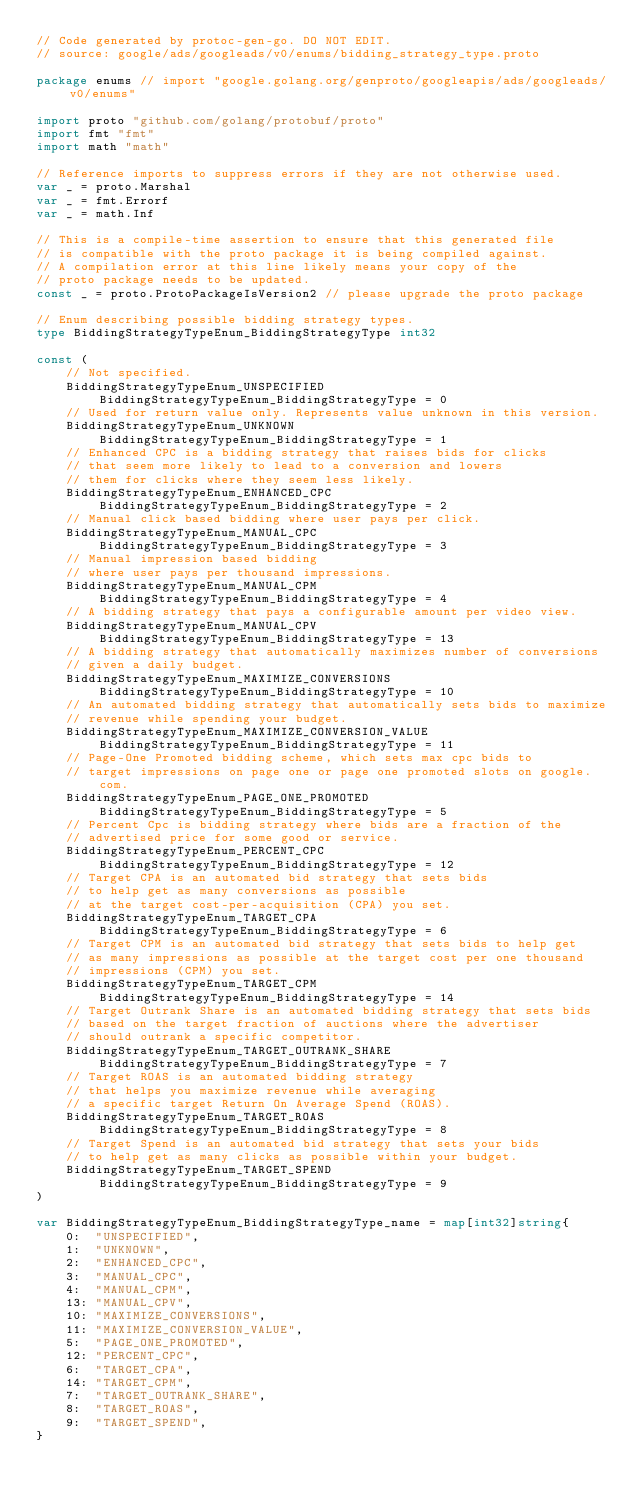<code> <loc_0><loc_0><loc_500><loc_500><_Go_>// Code generated by protoc-gen-go. DO NOT EDIT.
// source: google/ads/googleads/v0/enums/bidding_strategy_type.proto

package enums // import "google.golang.org/genproto/googleapis/ads/googleads/v0/enums"

import proto "github.com/golang/protobuf/proto"
import fmt "fmt"
import math "math"

// Reference imports to suppress errors if they are not otherwise used.
var _ = proto.Marshal
var _ = fmt.Errorf
var _ = math.Inf

// This is a compile-time assertion to ensure that this generated file
// is compatible with the proto package it is being compiled against.
// A compilation error at this line likely means your copy of the
// proto package needs to be updated.
const _ = proto.ProtoPackageIsVersion2 // please upgrade the proto package

// Enum describing possible bidding strategy types.
type BiddingStrategyTypeEnum_BiddingStrategyType int32

const (
	// Not specified.
	BiddingStrategyTypeEnum_UNSPECIFIED BiddingStrategyTypeEnum_BiddingStrategyType = 0
	// Used for return value only. Represents value unknown in this version.
	BiddingStrategyTypeEnum_UNKNOWN BiddingStrategyTypeEnum_BiddingStrategyType = 1
	// Enhanced CPC is a bidding strategy that raises bids for clicks
	// that seem more likely to lead to a conversion and lowers
	// them for clicks where they seem less likely.
	BiddingStrategyTypeEnum_ENHANCED_CPC BiddingStrategyTypeEnum_BiddingStrategyType = 2
	// Manual click based bidding where user pays per click.
	BiddingStrategyTypeEnum_MANUAL_CPC BiddingStrategyTypeEnum_BiddingStrategyType = 3
	// Manual impression based bidding
	// where user pays per thousand impressions.
	BiddingStrategyTypeEnum_MANUAL_CPM BiddingStrategyTypeEnum_BiddingStrategyType = 4
	// A bidding strategy that pays a configurable amount per video view.
	BiddingStrategyTypeEnum_MANUAL_CPV BiddingStrategyTypeEnum_BiddingStrategyType = 13
	// A bidding strategy that automatically maximizes number of conversions
	// given a daily budget.
	BiddingStrategyTypeEnum_MAXIMIZE_CONVERSIONS BiddingStrategyTypeEnum_BiddingStrategyType = 10
	// An automated bidding strategy that automatically sets bids to maximize
	// revenue while spending your budget.
	BiddingStrategyTypeEnum_MAXIMIZE_CONVERSION_VALUE BiddingStrategyTypeEnum_BiddingStrategyType = 11
	// Page-One Promoted bidding scheme, which sets max cpc bids to
	// target impressions on page one or page one promoted slots on google.com.
	BiddingStrategyTypeEnum_PAGE_ONE_PROMOTED BiddingStrategyTypeEnum_BiddingStrategyType = 5
	// Percent Cpc is bidding strategy where bids are a fraction of the
	// advertised price for some good or service.
	BiddingStrategyTypeEnum_PERCENT_CPC BiddingStrategyTypeEnum_BiddingStrategyType = 12
	// Target CPA is an automated bid strategy that sets bids
	// to help get as many conversions as possible
	// at the target cost-per-acquisition (CPA) you set.
	BiddingStrategyTypeEnum_TARGET_CPA BiddingStrategyTypeEnum_BiddingStrategyType = 6
	// Target CPM is an automated bid strategy that sets bids to help get
	// as many impressions as possible at the target cost per one thousand
	// impressions (CPM) you set.
	BiddingStrategyTypeEnum_TARGET_CPM BiddingStrategyTypeEnum_BiddingStrategyType = 14
	// Target Outrank Share is an automated bidding strategy that sets bids
	// based on the target fraction of auctions where the advertiser
	// should outrank a specific competitor.
	BiddingStrategyTypeEnum_TARGET_OUTRANK_SHARE BiddingStrategyTypeEnum_BiddingStrategyType = 7
	// Target ROAS is an automated bidding strategy
	// that helps you maximize revenue while averaging
	// a specific target Return On Average Spend (ROAS).
	BiddingStrategyTypeEnum_TARGET_ROAS BiddingStrategyTypeEnum_BiddingStrategyType = 8
	// Target Spend is an automated bid strategy that sets your bids
	// to help get as many clicks as possible within your budget.
	BiddingStrategyTypeEnum_TARGET_SPEND BiddingStrategyTypeEnum_BiddingStrategyType = 9
)

var BiddingStrategyTypeEnum_BiddingStrategyType_name = map[int32]string{
	0:  "UNSPECIFIED",
	1:  "UNKNOWN",
	2:  "ENHANCED_CPC",
	3:  "MANUAL_CPC",
	4:  "MANUAL_CPM",
	13: "MANUAL_CPV",
	10: "MAXIMIZE_CONVERSIONS",
	11: "MAXIMIZE_CONVERSION_VALUE",
	5:  "PAGE_ONE_PROMOTED",
	12: "PERCENT_CPC",
	6:  "TARGET_CPA",
	14: "TARGET_CPM",
	7:  "TARGET_OUTRANK_SHARE",
	8:  "TARGET_ROAS",
	9:  "TARGET_SPEND",
}</code> 